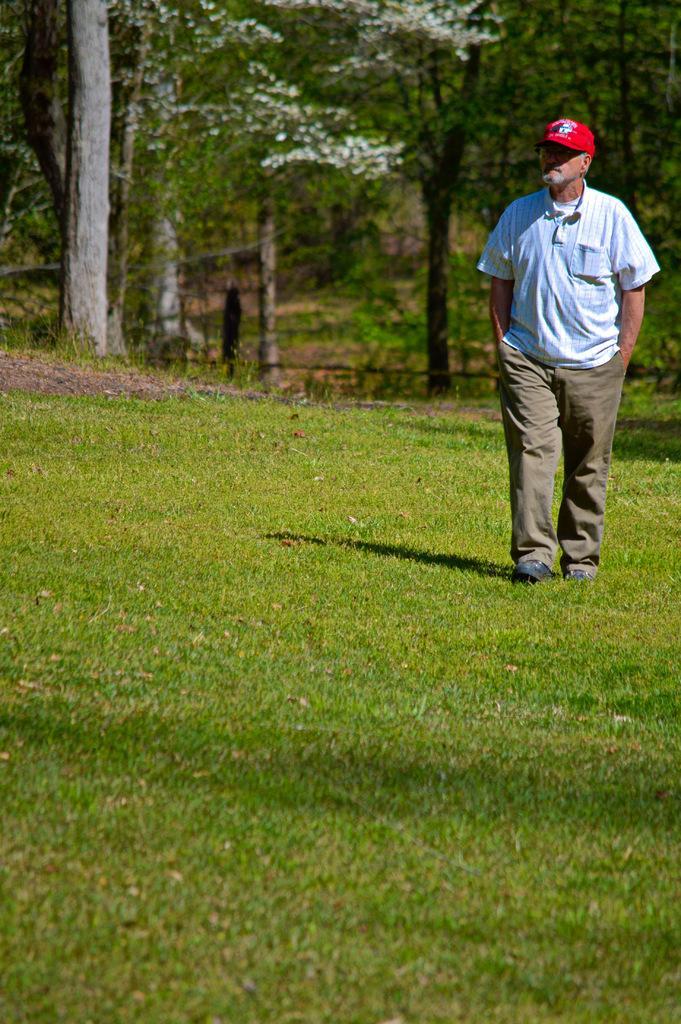Please provide a concise description of this image. In this image we can see a man walking on the ground. In the background there are trees. 